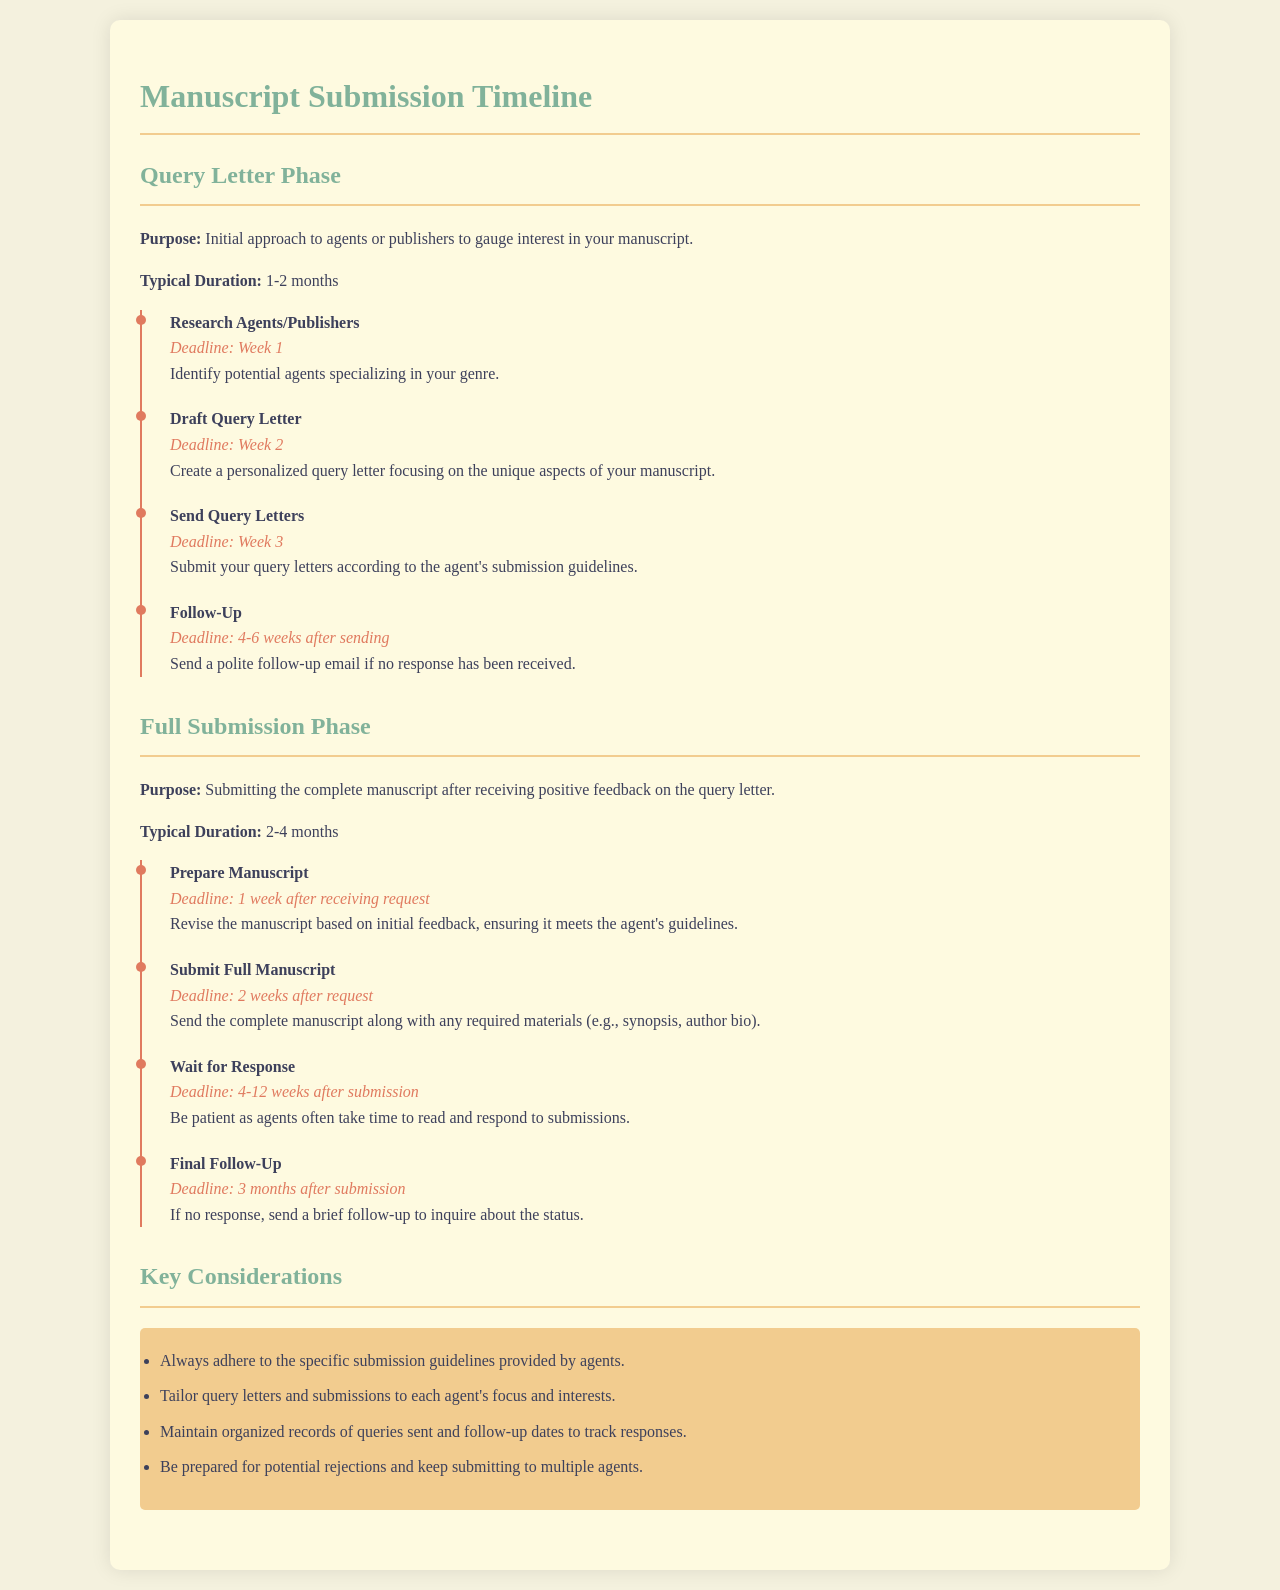What is the typical duration for the Query Letter Phase? The document states that the typical duration for the Query Letter Phase is 1-2 months.
Answer: 1-2 months What is the deadline for sending Query Letters? According to the document, the deadline for sending Query Letters is Week 3.
Answer: Week 3 How long should one wait for a response after full manuscript submission? The document mentions that one should wait for a response 4-12 weeks after submission.
Answer: 4-12 weeks What action should be taken if there is no response 3 months after submission? The document advises sending a brief follow-up to inquire about the status if no response is received after 3 months.
Answer: Brief follow-up What is the purpose of the Follow-Up step in the Query Letter Phase? The document states that the purpose of the Follow-Up step is to send a polite follow-up email if no response has been received.
Answer: Polite follow-up email What should be prepared after receiving a request for a full manuscript? The document indicates that one should prepare the manuscript by revising it based on initial feedback.
Answer: Prepare manuscript What are two key considerations when submitting manuscripts? The document lists several considerations, two of which are to adhere to submission guidelines and tailor materials to each agent's interests.
Answer: Adhere to guidelines, tailor materials What is the deadline for preparing the manuscript? The document specifies that the deadline for preparing the manuscript is 1 week after receiving the request.
Answer: 1 week after request 